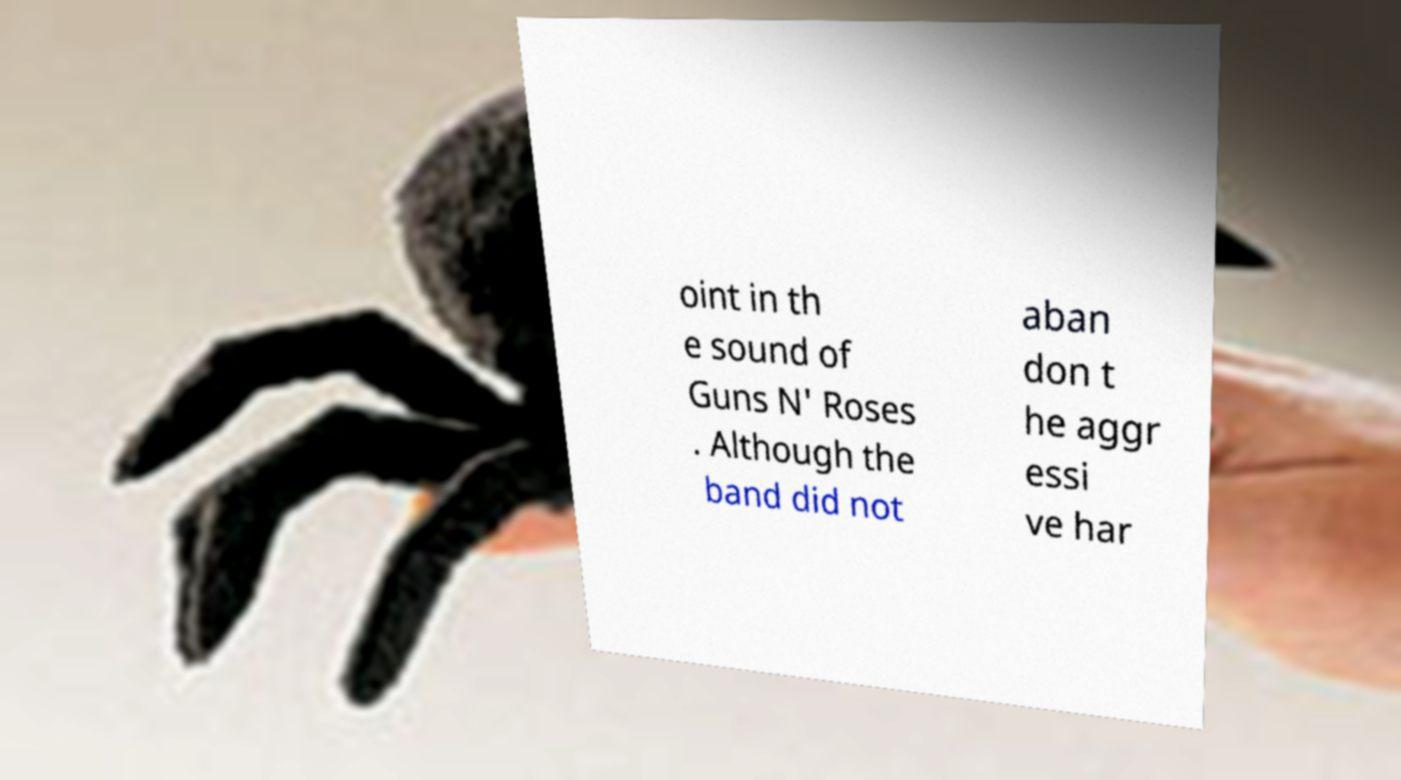I need the written content from this picture converted into text. Can you do that? oint in th e sound of Guns N' Roses . Although the band did not aban don t he aggr essi ve har 